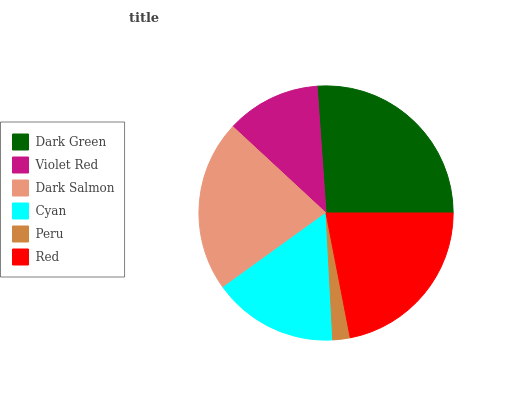Is Peru the minimum?
Answer yes or no. Yes. Is Dark Green the maximum?
Answer yes or no. Yes. Is Violet Red the minimum?
Answer yes or no. No. Is Violet Red the maximum?
Answer yes or no. No. Is Dark Green greater than Violet Red?
Answer yes or no. Yes. Is Violet Red less than Dark Green?
Answer yes or no. Yes. Is Violet Red greater than Dark Green?
Answer yes or no. No. Is Dark Green less than Violet Red?
Answer yes or no. No. Is Dark Salmon the high median?
Answer yes or no. Yes. Is Cyan the low median?
Answer yes or no. Yes. Is Dark Green the high median?
Answer yes or no. No. Is Dark Green the low median?
Answer yes or no. No. 